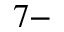Convert formula to latex. <formula><loc_0><loc_0><loc_500><loc_500>^ { 7 - }</formula> 